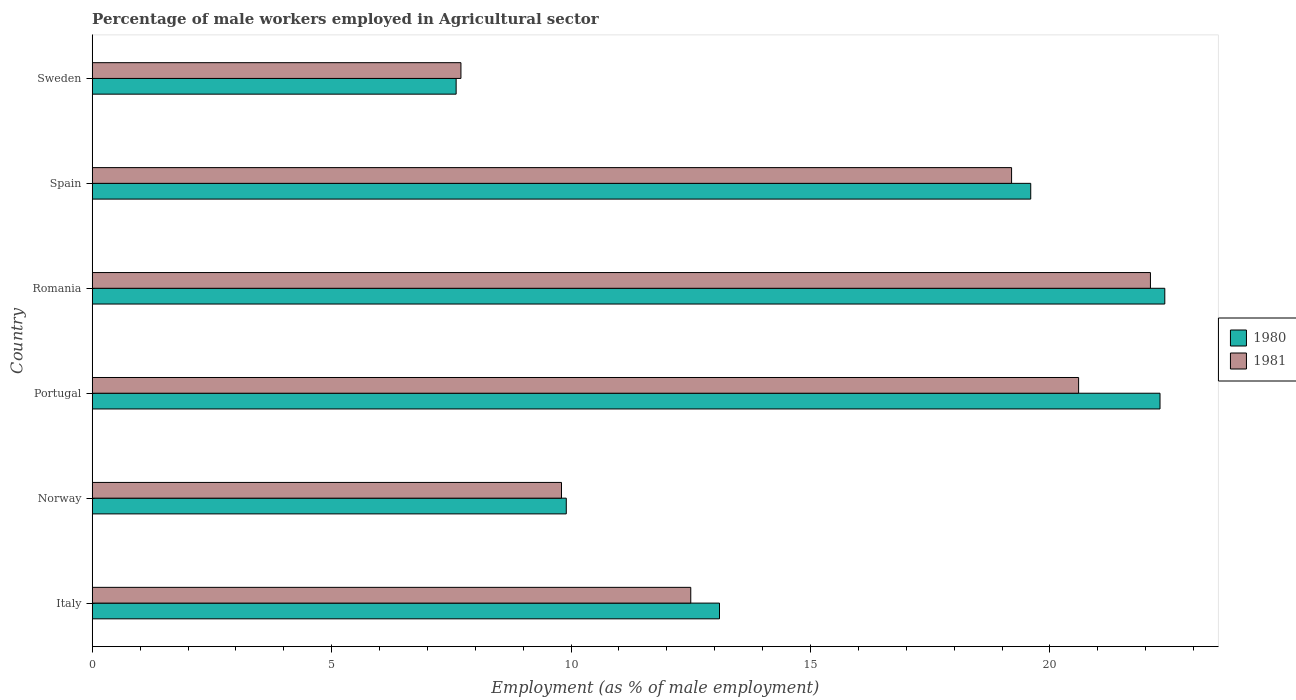How many different coloured bars are there?
Your answer should be compact. 2. Are the number of bars per tick equal to the number of legend labels?
Make the answer very short. Yes. Are the number of bars on each tick of the Y-axis equal?
Offer a terse response. Yes. How many bars are there on the 4th tick from the bottom?
Ensure brevity in your answer.  2. What is the label of the 3rd group of bars from the top?
Offer a very short reply. Romania. What is the percentage of male workers employed in Agricultural sector in 1980 in Sweden?
Keep it short and to the point. 7.6. Across all countries, what is the maximum percentage of male workers employed in Agricultural sector in 1981?
Offer a very short reply. 22.1. Across all countries, what is the minimum percentage of male workers employed in Agricultural sector in 1981?
Keep it short and to the point. 7.7. In which country was the percentage of male workers employed in Agricultural sector in 1980 maximum?
Your answer should be compact. Romania. In which country was the percentage of male workers employed in Agricultural sector in 1981 minimum?
Offer a terse response. Sweden. What is the total percentage of male workers employed in Agricultural sector in 1981 in the graph?
Ensure brevity in your answer.  91.9. What is the difference between the percentage of male workers employed in Agricultural sector in 1980 in Italy and that in Sweden?
Make the answer very short. 5.5. What is the difference between the percentage of male workers employed in Agricultural sector in 1981 in Spain and the percentage of male workers employed in Agricultural sector in 1980 in Portugal?
Make the answer very short. -3.1. What is the average percentage of male workers employed in Agricultural sector in 1980 per country?
Your answer should be compact. 15.82. What is the difference between the percentage of male workers employed in Agricultural sector in 1980 and percentage of male workers employed in Agricultural sector in 1981 in Sweden?
Offer a very short reply. -0.1. What is the ratio of the percentage of male workers employed in Agricultural sector in 1981 in Romania to that in Spain?
Your answer should be very brief. 1.15. Is the percentage of male workers employed in Agricultural sector in 1981 in Romania less than that in Sweden?
Provide a short and direct response. No. Is the difference between the percentage of male workers employed in Agricultural sector in 1980 in Norway and Sweden greater than the difference between the percentage of male workers employed in Agricultural sector in 1981 in Norway and Sweden?
Your answer should be compact. Yes. What is the difference between the highest and the second highest percentage of male workers employed in Agricultural sector in 1980?
Give a very brief answer. 0.1. What is the difference between the highest and the lowest percentage of male workers employed in Agricultural sector in 1981?
Keep it short and to the point. 14.4. In how many countries, is the percentage of male workers employed in Agricultural sector in 1980 greater than the average percentage of male workers employed in Agricultural sector in 1980 taken over all countries?
Give a very brief answer. 3. Is the sum of the percentage of male workers employed in Agricultural sector in 1980 in Portugal and Sweden greater than the maximum percentage of male workers employed in Agricultural sector in 1981 across all countries?
Keep it short and to the point. Yes. What does the 2nd bar from the top in Italy represents?
Keep it short and to the point. 1980. What is the difference between two consecutive major ticks on the X-axis?
Make the answer very short. 5. Does the graph contain any zero values?
Offer a terse response. No. How are the legend labels stacked?
Your response must be concise. Vertical. What is the title of the graph?
Offer a terse response. Percentage of male workers employed in Agricultural sector. Does "1991" appear as one of the legend labels in the graph?
Make the answer very short. No. What is the label or title of the X-axis?
Your answer should be very brief. Employment (as % of male employment). What is the Employment (as % of male employment) in 1980 in Italy?
Your answer should be compact. 13.1. What is the Employment (as % of male employment) in 1981 in Italy?
Provide a short and direct response. 12.5. What is the Employment (as % of male employment) in 1980 in Norway?
Provide a short and direct response. 9.9. What is the Employment (as % of male employment) in 1981 in Norway?
Provide a short and direct response. 9.8. What is the Employment (as % of male employment) of 1980 in Portugal?
Make the answer very short. 22.3. What is the Employment (as % of male employment) of 1981 in Portugal?
Make the answer very short. 20.6. What is the Employment (as % of male employment) in 1980 in Romania?
Provide a succinct answer. 22.4. What is the Employment (as % of male employment) in 1981 in Romania?
Give a very brief answer. 22.1. What is the Employment (as % of male employment) in 1980 in Spain?
Your answer should be very brief. 19.6. What is the Employment (as % of male employment) in 1981 in Spain?
Provide a short and direct response. 19.2. What is the Employment (as % of male employment) in 1980 in Sweden?
Your answer should be compact. 7.6. What is the Employment (as % of male employment) of 1981 in Sweden?
Your answer should be very brief. 7.7. Across all countries, what is the maximum Employment (as % of male employment) of 1980?
Your response must be concise. 22.4. Across all countries, what is the maximum Employment (as % of male employment) in 1981?
Ensure brevity in your answer.  22.1. Across all countries, what is the minimum Employment (as % of male employment) in 1980?
Your answer should be very brief. 7.6. Across all countries, what is the minimum Employment (as % of male employment) of 1981?
Your response must be concise. 7.7. What is the total Employment (as % of male employment) of 1980 in the graph?
Keep it short and to the point. 94.9. What is the total Employment (as % of male employment) of 1981 in the graph?
Make the answer very short. 91.9. What is the difference between the Employment (as % of male employment) in 1981 in Italy and that in Norway?
Offer a terse response. 2.7. What is the difference between the Employment (as % of male employment) in 1980 in Italy and that in Romania?
Give a very brief answer. -9.3. What is the difference between the Employment (as % of male employment) in 1981 in Italy and that in Romania?
Offer a terse response. -9.6. What is the difference between the Employment (as % of male employment) of 1981 in Italy and that in Spain?
Provide a short and direct response. -6.7. What is the difference between the Employment (as % of male employment) in 1981 in Italy and that in Sweden?
Keep it short and to the point. 4.8. What is the difference between the Employment (as % of male employment) of 1980 in Norway and that in Portugal?
Your answer should be compact. -12.4. What is the difference between the Employment (as % of male employment) of 1981 in Norway and that in Portugal?
Your answer should be compact. -10.8. What is the difference between the Employment (as % of male employment) in 1980 in Norway and that in Romania?
Your answer should be compact. -12.5. What is the difference between the Employment (as % of male employment) in 1980 in Norway and that in Spain?
Provide a short and direct response. -9.7. What is the difference between the Employment (as % of male employment) in 1981 in Norway and that in Sweden?
Provide a short and direct response. 2.1. What is the difference between the Employment (as % of male employment) of 1980 in Portugal and that in Romania?
Make the answer very short. -0.1. What is the difference between the Employment (as % of male employment) in 1980 in Portugal and that in Spain?
Ensure brevity in your answer.  2.7. What is the difference between the Employment (as % of male employment) in 1980 in Portugal and that in Sweden?
Offer a terse response. 14.7. What is the difference between the Employment (as % of male employment) in 1981 in Portugal and that in Sweden?
Your answer should be very brief. 12.9. What is the difference between the Employment (as % of male employment) of 1980 in Romania and that in Spain?
Give a very brief answer. 2.8. What is the difference between the Employment (as % of male employment) of 1981 in Romania and that in Spain?
Make the answer very short. 2.9. What is the difference between the Employment (as % of male employment) of 1980 in Romania and that in Sweden?
Your answer should be very brief. 14.8. What is the difference between the Employment (as % of male employment) of 1980 in Spain and that in Sweden?
Your answer should be compact. 12. What is the difference between the Employment (as % of male employment) of 1980 in Italy and the Employment (as % of male employment) of 1981 in Portugal?
Provide a short and direct response. -7.5. What is the difference between the Employment (as % of male employment) in 1980 in Italy and the Employment (as % of male employment) in 1981 in Romania?
Your answer should be very brief. -9. What is the difference between the Employment (as % of male employment) of 1980 in Italy and the Employment (as % of male employment) of 1981 in Spain?
Offer a very short reply. -6.1. What is the difference between the Employment (as % of male employment) of 1980 in Norway and the Employment (as % of male employment) of 1981 in Portugal?
Ensure brevity in your answer.  -10.7. What is the difference between the Employment (as % of male employment) of 1980 in Norway and the Employment (as % of male employment) of 1981 in Spain?
Give a very brief answer. -9.3. What is the difference between the Employment (as % of male employment) in 1980 in Portugal and the Employment (as % of male employment) in 1981 in Spain?
Offer a very short reply. 3.1. What is the average Employment (as % of male employment) in 1980 per country?
Your answer should be compact. 15.82. What is the average Employment (as % of male employment) of 1981 per country?
Make the answer very short. 15.32. What is the difference between the Employment (as % of male employment) of 1980 and Employment (as % of male employment) of 1981 in Italy?
Your answer should be very brief. 0.6. What is the difference between the Employment (as % of male employment) in 1980 and Employment (as % of male employment) in 1981 in Norway?
Offer a very short reply. 0.1. What is the ratio of the Employment (as % of male employment) of 1980 in Italy to that in Norway?
Your answer should be compact. 1.32. What is the ratio of the Employment (as % of male employment) of 1981 in Italy to that in Norway?
Offer a terse response. 1.28. What is the ratio of the Employment (as % of male employment) of 1980 in Italy to that in Portugal?
Your answer should be compact. 0.59. What is the ratio of the Employment (as % of male employment) of 1981 in Italy to that in Portugal?
Provide a succinct answer. 0.61. What is the ratio of the Employment (as % of male employment) of 1980 in Italy to that in Romania?
Offer a very short reply. 0.58. What is the ratio of the Employment (as % of male employment) of 1981 in Italy to that in Romania?
Offer a terse response. 0.57. What is the ratio of the Employment (as % of male employment) of 1980 in Italy to that in Spain?
Offer a very short reply. 0.67. What is the ratio of the Employment (as % of male employment) in 1981 in Italy to that in Spain?
Provide a succinct answer. 0.65. What is the ratio of the Employment (as % of male employment) in 1980 in Italy to that in Sweden?
Provide a short and direct response. 1.72. What is the ratio of the Employment (as % of male employment) of 1981 in Italy to that in Sweden?
Your answer should be very brief. 1.62. What is the ratio of the Employment (as % of male employment) of 1980 in Norway to that in Portugal?
Offer a terse response. 0.44. What is the ratio of the Employment (as % of male employment) of 1981 in Norway to that in Portugal?
Keep it short and to the point. 0.48. What is the ratio of the Employment (as % of male employment) in 1980 in Norway to that in Romania?
Ensure brevity in your answer.  0.44. What is the ratio of the Employment (as % of male employment) of 1981 in Norway to that in Romania?
Ensure brevity in your answer.  0.44. What is the ratio of the Employment (as % of male employment) in 1980 in Norway to that in Spain?
Make the answer very short. 0.51. What is the ratio of the Employment (as % of male employment) of 1981 in Norway to that in Spain?
Your answer should be compact. 0.51. What is the ratio of the Employment (as % of male employment) in 1980 in Norway to that in Sweden?
Your answer should be very brief. 1.3. What is the ratio of the Employment (as % of male employment) of 1981 in Norway to that in Sweden?
Keep it short and to the point. 1.27. What is the ratio of the Employment (as % of male employment) in 1981 in Portugal to that in Romania?
Provide a succinct answer. 0.93. What is the ratio of the Employment (as % of male employment) of 1980 in Portugal to that in Spain?
Provide a succinct answer. 1.14. What is the ratio of the Employment (as % of male employment) of 1981 in Portugal to that in Spain?
Your answer should be very brief. 1.07. What is the ratio of the Employment (as % of male employment) in 1980 in Portugal to that in Sweden?
Give a very brief answer. 2.93. What is the ratio of the Employment (as % of male employment) in 1981 in Portugal to that in Sweden?
Offer a very short reply. 2.68. What is the ratio of the Employment (as % of male employment) of 1981 in Romania to that in Spain?
Keep it short and to the point. 1.15. What is the ratio of the Employment (as % of male employment) of 1980 in Romania to that in Sweden?
Offer a very short reply. 2.95. What is the ratio of the Employment (as % of male employment) in 1981 in Romania to that in Sweden?
Ensure brevity in your answer.  2.87. What is the ratio of the Employment (as % of male employment) in 1980 in Spain to that in Sweden?
Your answer should be compact. 2.58. What is the ratio of the Employment (as % of male employment) in 1981 in Spain to that in Sweden?
Provide a short and direct response. 2.49. What is the difference between the highest and the second highest Employment (as % of male employment) of 1980?
Offer a very short reply. 0.1. What is the difference between the highest and the lowest Employment (as % of male employment) of 1980?
Make the answer very short. 14.8. 